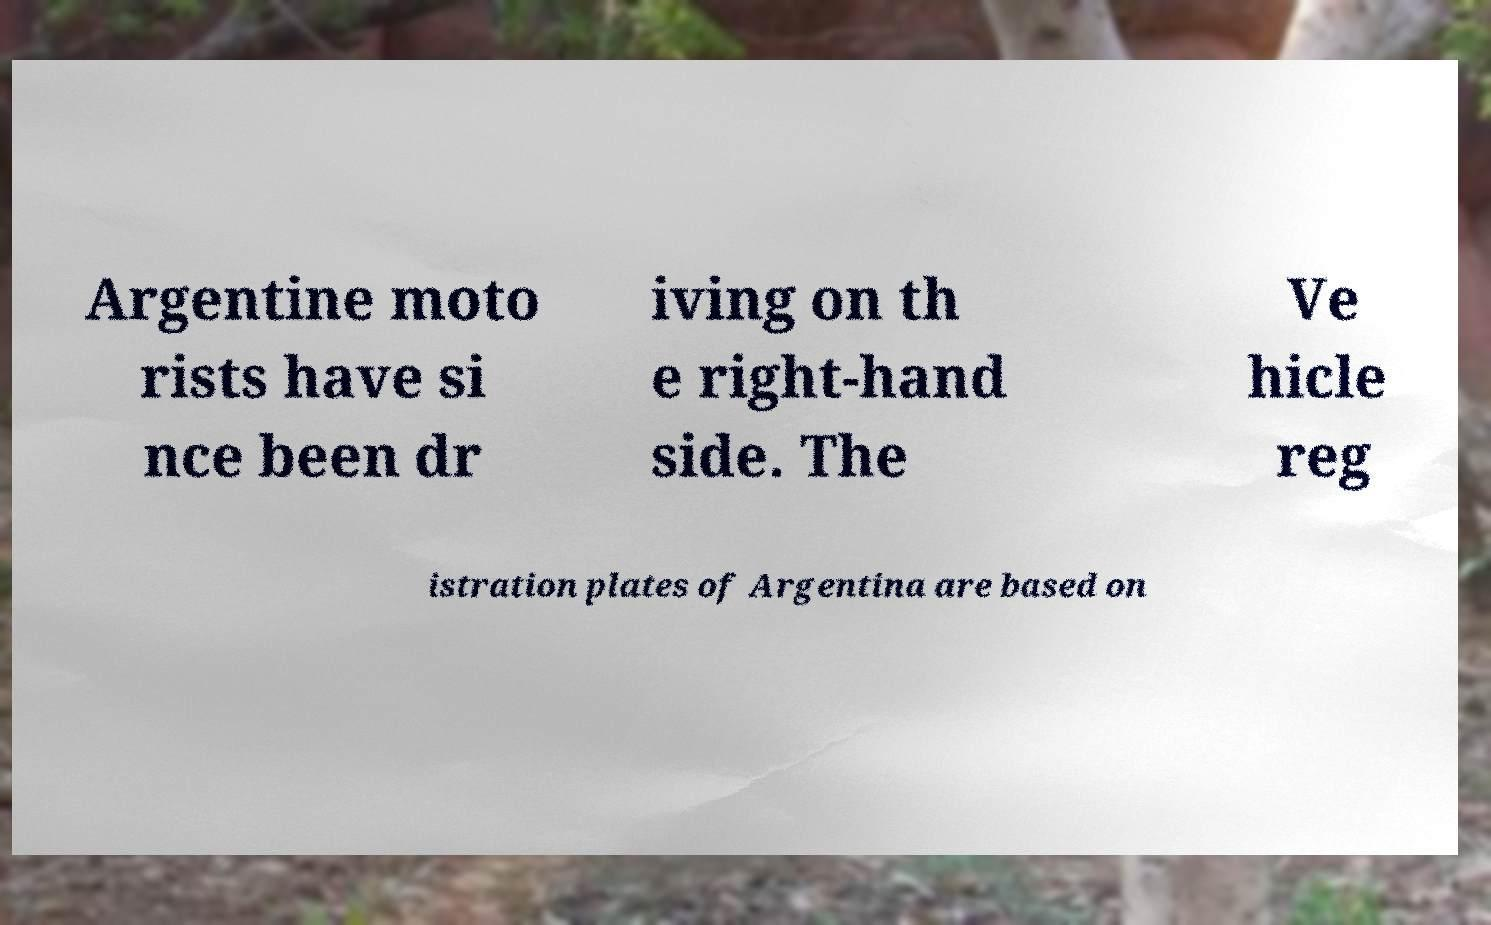Please identify and transcribe the text found in this image. Argentine moto rists have si nce been dr iving on th e right-hand side. The Ve hicle reg istration plates of Argentina are based on 